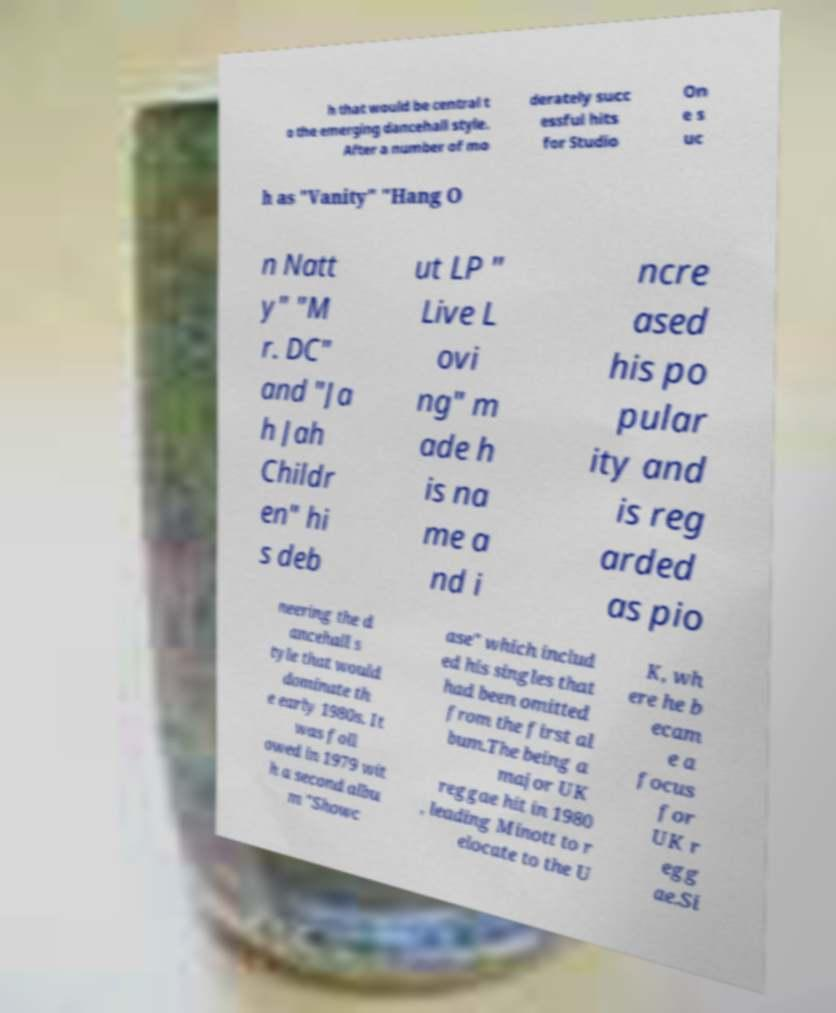I need the written content from this picture converted into text. Can you do that? h that would be central t o the emerging dancehall style. After a number of mo derately succ essful hits for Studio On e s uc h as "Vanity" "Hang O n Natt y" "M r. DC" and "Ja h Jah Childr en" hi s deb ut LP " Live L ovi ng" m ade h is na me a nd i ncre ased his po pular ity and is reg arded as pio neering the d ancehall s tyle that would dominate th e early 1980s. It was foll owed in 1979 wit h a second albu m "Showc ase" which includ ed his singles that had been omitted from the first al bum.The being a major UK reggae hit in 1980 , leading Minott to r elocate to the U K, wh ere he b ecam e a focus for UK r egg ae.Si 